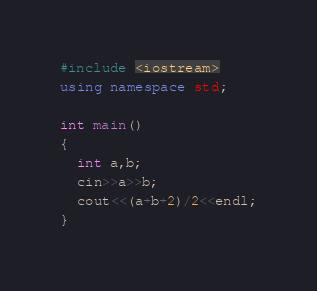<code> <loc_0><loc_0><loc_500><loc_500><_C++_>#include <iostream>
using namespace std;

int main()
{
  int a,b;
  cin>>a>>b;
  cout<<(a+b+2)/2<<endl;
}</code> 